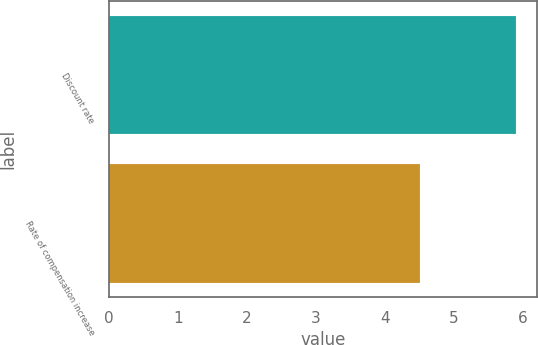Convert chart to OTSL. <chart><loc_0><loc_0><loc_500><loc_500><bar_chart><fcel>Discount rate<fcel>Rate of compensation increase<nl><fcel>5.9<fcel>4.5<nl></chart> 